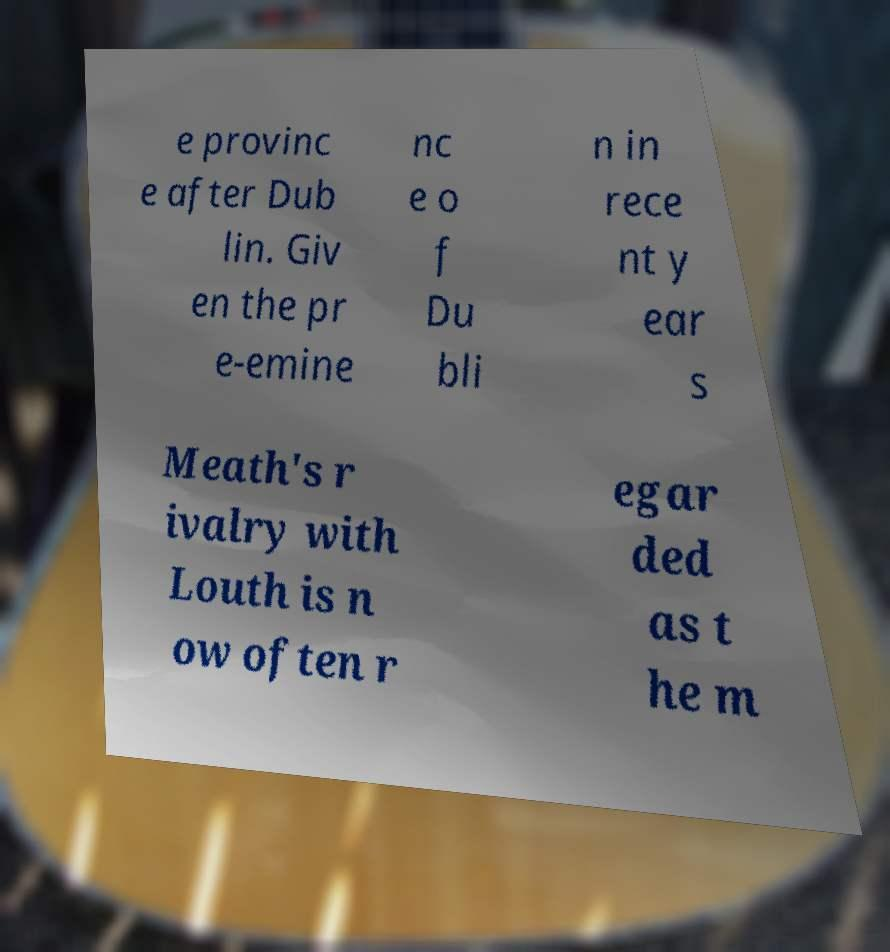Can you accurately transcribe the text from the provided image for me? e provinc e after Dub lin. Giv en the pr e-emine nc e o f Du bli n in rece nt y ear s Meath's r ivalry with Louth is n ow often r egar ded as t he m 